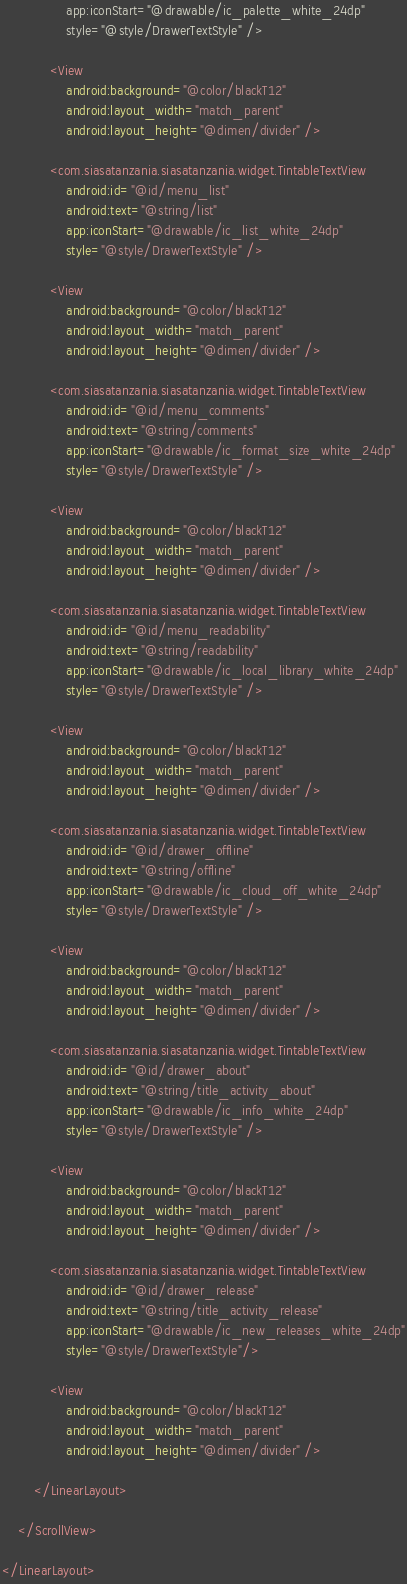Convert code to text. <code><loc_0><loc_0><loc_500><loc_500><_XML_>                app:iconStart="@drawable/ic_palette_white_24dp"
                style="@style/DrawerTextStyle" />

            <View
                android:background="@color/blackT12"
                android:layout_width="match_parent"
                android:layout_height="@dimen/divider" />

            <com.siasatanzania.siasatanzania.widget.TintableTextView
                android:id="@id/menu_list"
                android:text="@string/list"
                app:iconStart="@drawable/ic_list_white_24dp"
                style="@style/DrawerTextStyle" />

            <View
                android:background="@color/blackT12"
                android:layout_width="match_parent"
                android:layout_height="@dimen/divider" />

            <com.siasatanzania.siasatanzania.widget.TintableTextView
                android:id="@id/menu_comments"
                android:text="@string/comments"
                app:iconStart="@drawable/ic_format_size_white_24dp"
                style="@style/DrawerTextStyle" />

            <View
                android:background="@color/blackT12"
                android:layout_width="match_parent"
                android:layout_height="@dimen/divider" />

            <com.siasatanzania.siasatanzania.widget.TintableTextView
                android:id="@id/menu_readability"
                android:text="@string/readability"
                app:iconStart="@drawable/ic_local_library_white_24dp"
                style="@style/DrawerTextStyle" />

            <View
                android:background="@color/blackT12"
                android:layout_width="match_parent"
                android:layout_height="@dimen/divider" />

            <com.siasatanzania.siasatanzania.widget.TintableTextView
                android:id="@id/drawer_offline"
                android:text="@string/offline"
                app:iconStart="@drawable/ic_cloud_off_white_24dp"
                style="@style/DrawerTextStyle" />

            <View
                android:background="@color/blackT12"
                android:layout_width="match_parent"
                android:layout_height="@dimen/divider" />

            <com.siasatanzania.siasatanzania.widget.TintableTextView
                android:id="@id/drawer_about"
                android:text="@string/title_activity_about"
                app:iconStart="@drawable/ic_info_white_24dp"
                style="@style/DrawerTextStyle" />

            <View
                android:background="@color/blackT12"
                android:layout_width="match_parent"
                android:layout_height="@dimen/divider" />

            <com.siasatanzania.siasatanzania.widget.TintableTextView
                android:id="@id/drawer_release"
                android:text="@string/title_activity_release"
                app:iconStart="@drawable/ic_new_releases_white_24dp"
                style="@style/DrawerTextStyle"/>

            <View
                android:background="@color/blackT12"
                android:layout_width="match_parent"
                android:layout_height="@dimen/divider" />

        </LinearLayout>

    </ScrollView>

</LinearLayout></code> 